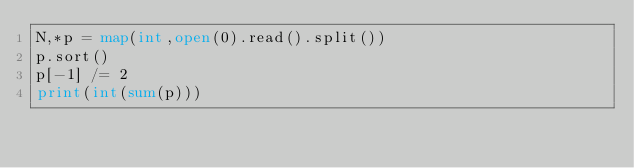Convert code to text. <code><loc_0><loc_0><loc_500><loc_500><_Python_>N,*p = map(int,open(0).read().split())
p.sort()
p[-1] /= 2
print(int(sum(p)))
</code> 